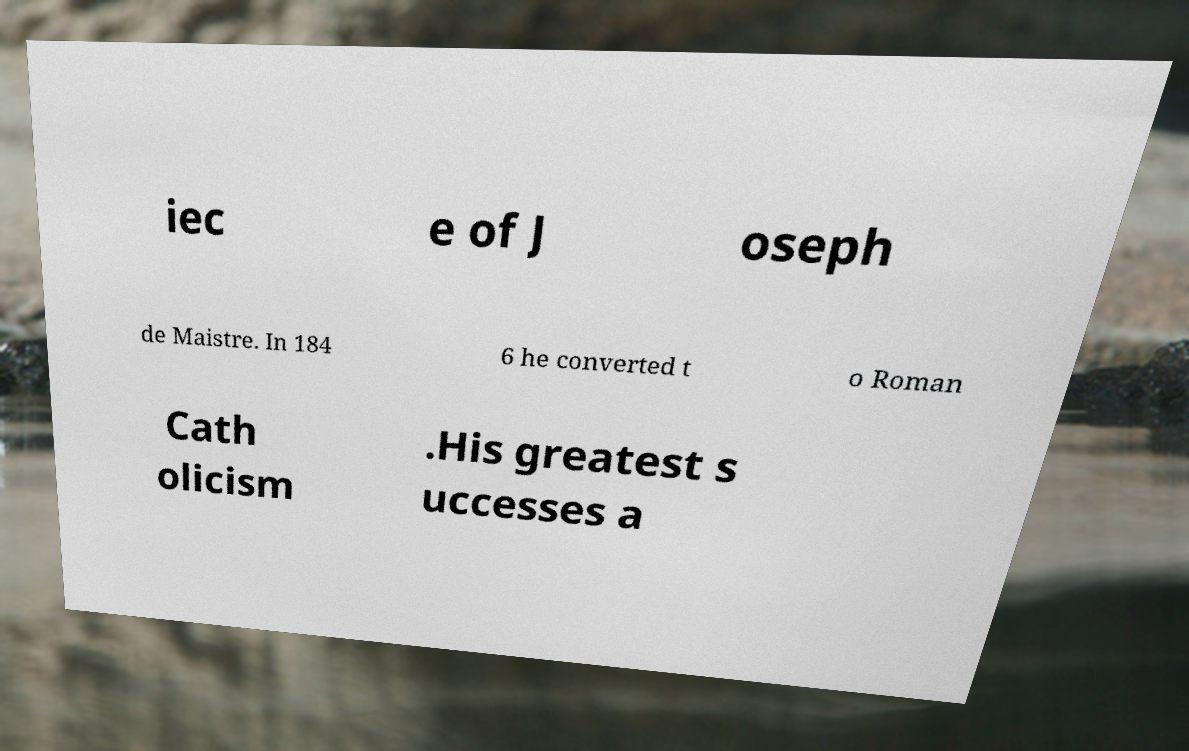There's text embedded in this image that I need extracted. Can you transcribe it verbatim? iec e of J oseph de Maistre. In 184 6 he converted t o Roman Cath olicism .His greatest s uccesses a 